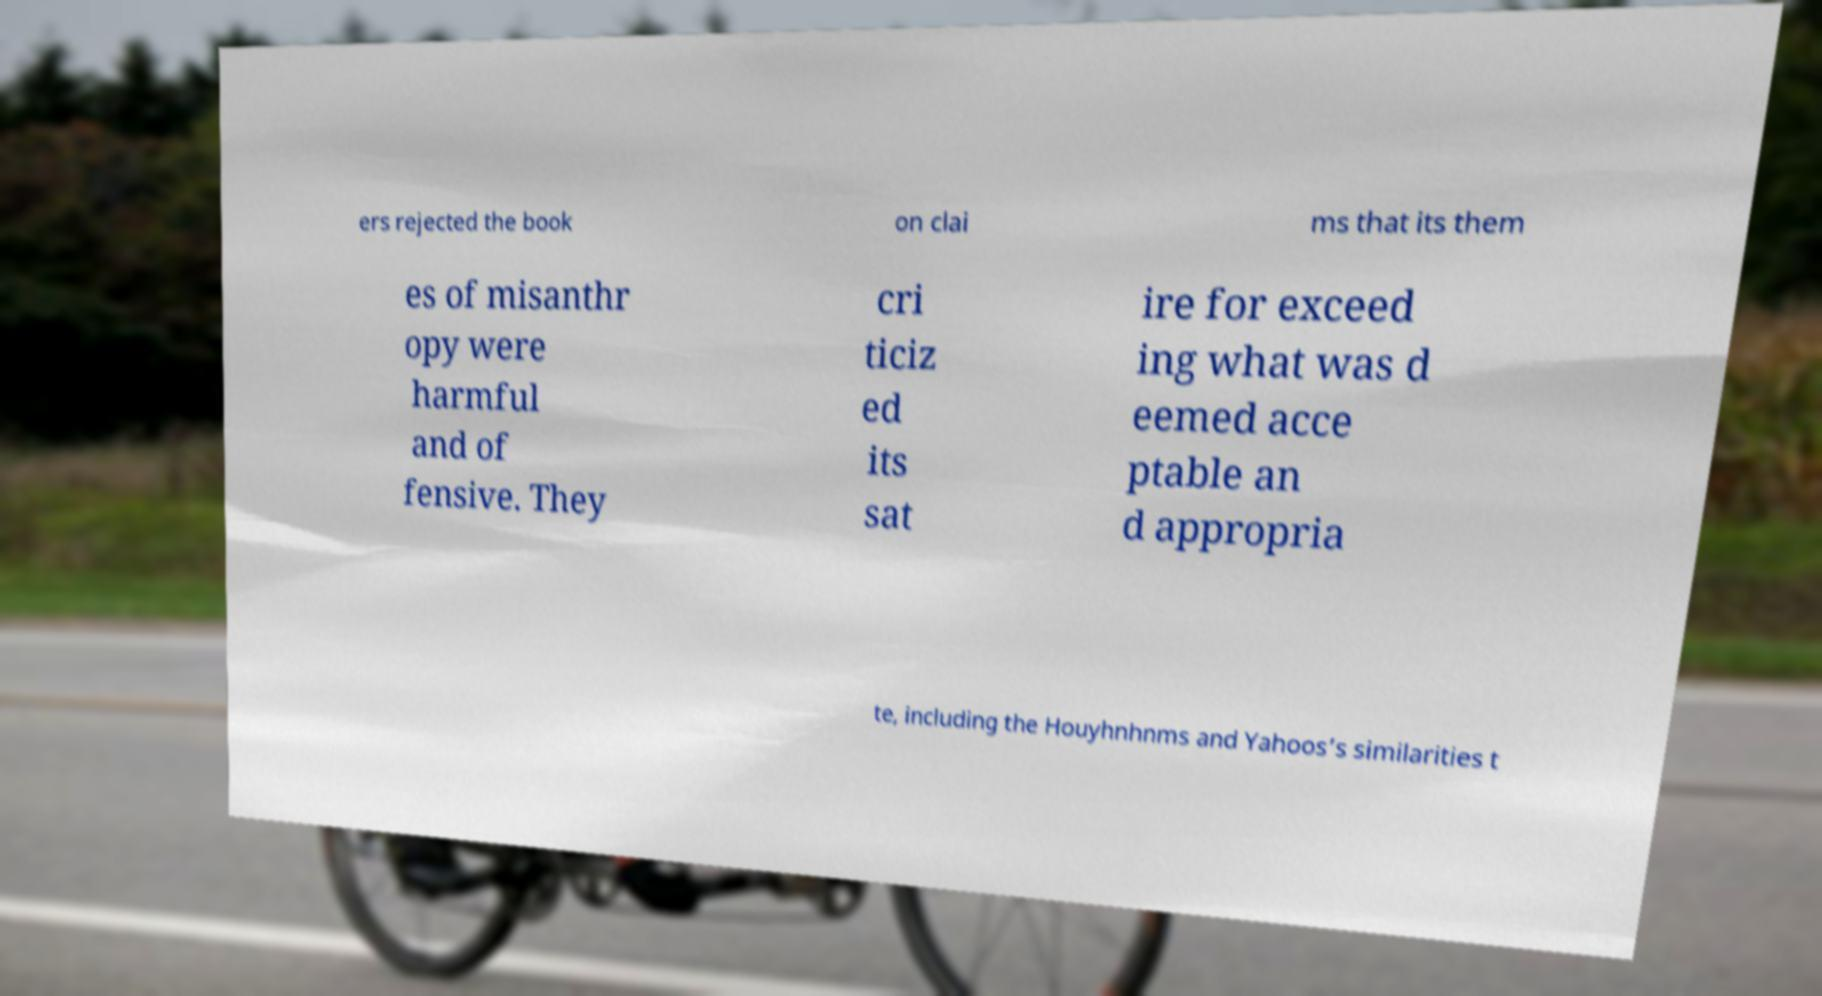There's text embedded in this image that I need extracted. Can you transcribe it verbatim? ers rejected the book on clai ms that its them es of misanthr opy were harmful and of fensive. They cri ticiz ed its sat ire for exceed ing what was d eemed acce ptable an d appropria te, including the Houyhnhnms and Yahoos’s similarities t 